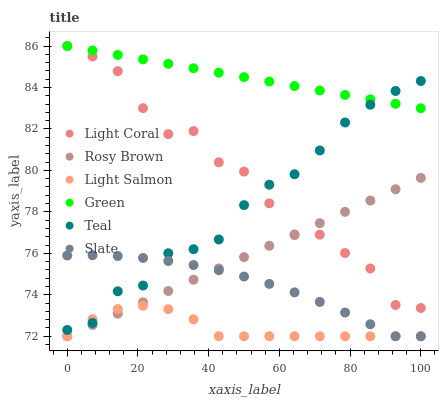Does Light Salmon have the minimum area under the curve?
Answer yes or no. Yes. Does Green have the maximum area under the curve?
Answer yes or no. Yes. Does Slate have the minimum area under the curve?
Answer yes or no. No. Does Slate have the maximum area under the curve?
Answer yes or no. No. Is Green the smoothest?
Answer yes or no. Yes. Is Light Coral the roughest?
Answer yes or no. Yes. Is Slate the smoothest?
Answer yes or no. No. Is Slate the roughest?
Answer yes or no. No. Does Light Salmon have the lowest value?
Answer yes or no. Yes. Does Light Coral have the lowest value?
Answer yes or no. No. Does Green have the highest value?
Answer yes or no. Yes. Does Slate have the highest value?
Answer yes or no. No. Is Slate less than Green?
Answer yes or no. Yes. Is Teal greater than Rosy Brown?
Answer yes or no. Yes. Does Rosy Brown intersect Light Salmon?
Answer yes or no. Yes. Is Rosy Brown less than Light Salmon?
Answer yes or no. No. Is Rosy Brown greater than Light Salmon?
Answer yes or no. No. Does Slate intersect Green?
Answer yes or no. No. 